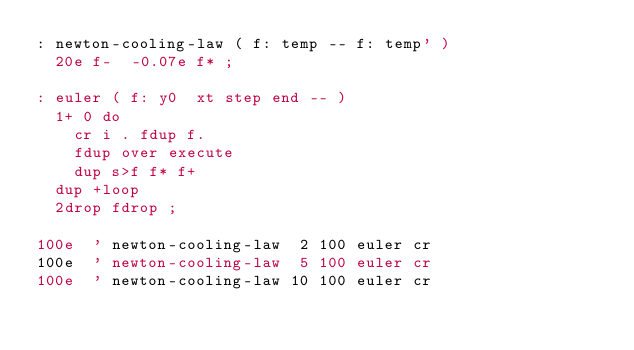<code> <loc_0><loc_0><loc_500><loc_500><_Forth_>: newton-cooling-law ( f: temp -- f: temp' )
  20e f-  -0.07e f* ;

: euler ( f: y0  xt step end -- )
  1+ 0 do
    cr i . fdup f.
    fdup over execute
    dup s>f f* f+
  dup +loop
  2drop fdrop ;

100e  ' newton-cooling-law  2 100 euler cr
100e  ' newton-cooling-law  5 100 euler cr
100e  ' newton-cooling-law 10 100 euler cr
</code> 